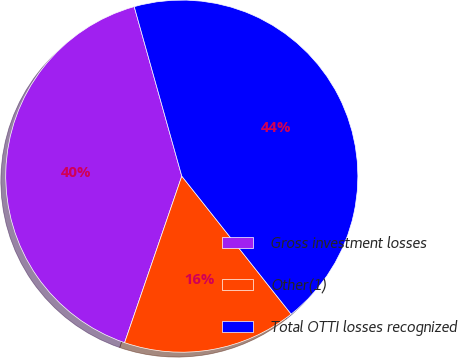Convert chart. <chart><loc_0><loc_0><loc_500><loc_500><pie_chart><fcel>Gross investment losses<fcel>Other(1)<fcel>Total OTTI losses recognized<nl><fcel>40.38%<fcel>15.93%<fcel>43.69%<nl></chart> 